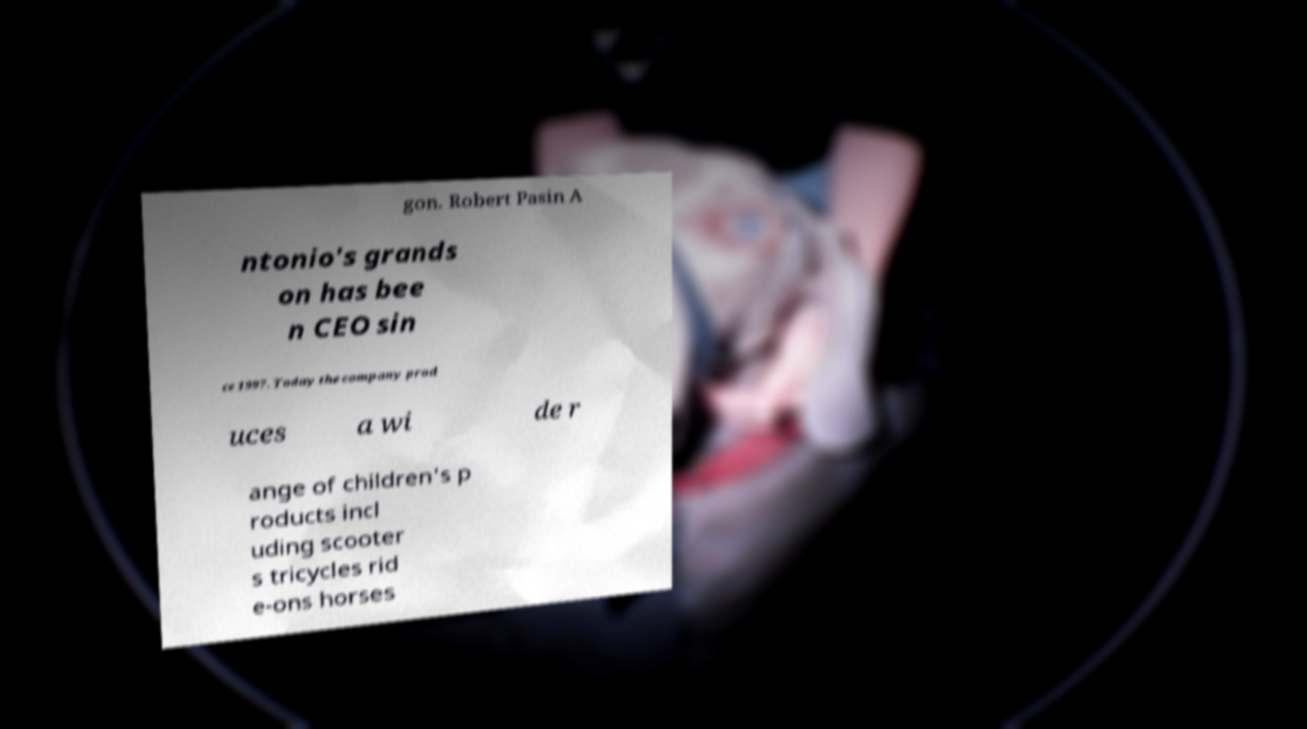Please identify and transcribe the text found in this image. gon. Robert Pasin A ntonio's grands on has bee n CEO sin ce 1997. Today the company prod uces a wi de r ange of children's p roducts incl uding scooter s tricycles rid e-ons horses 